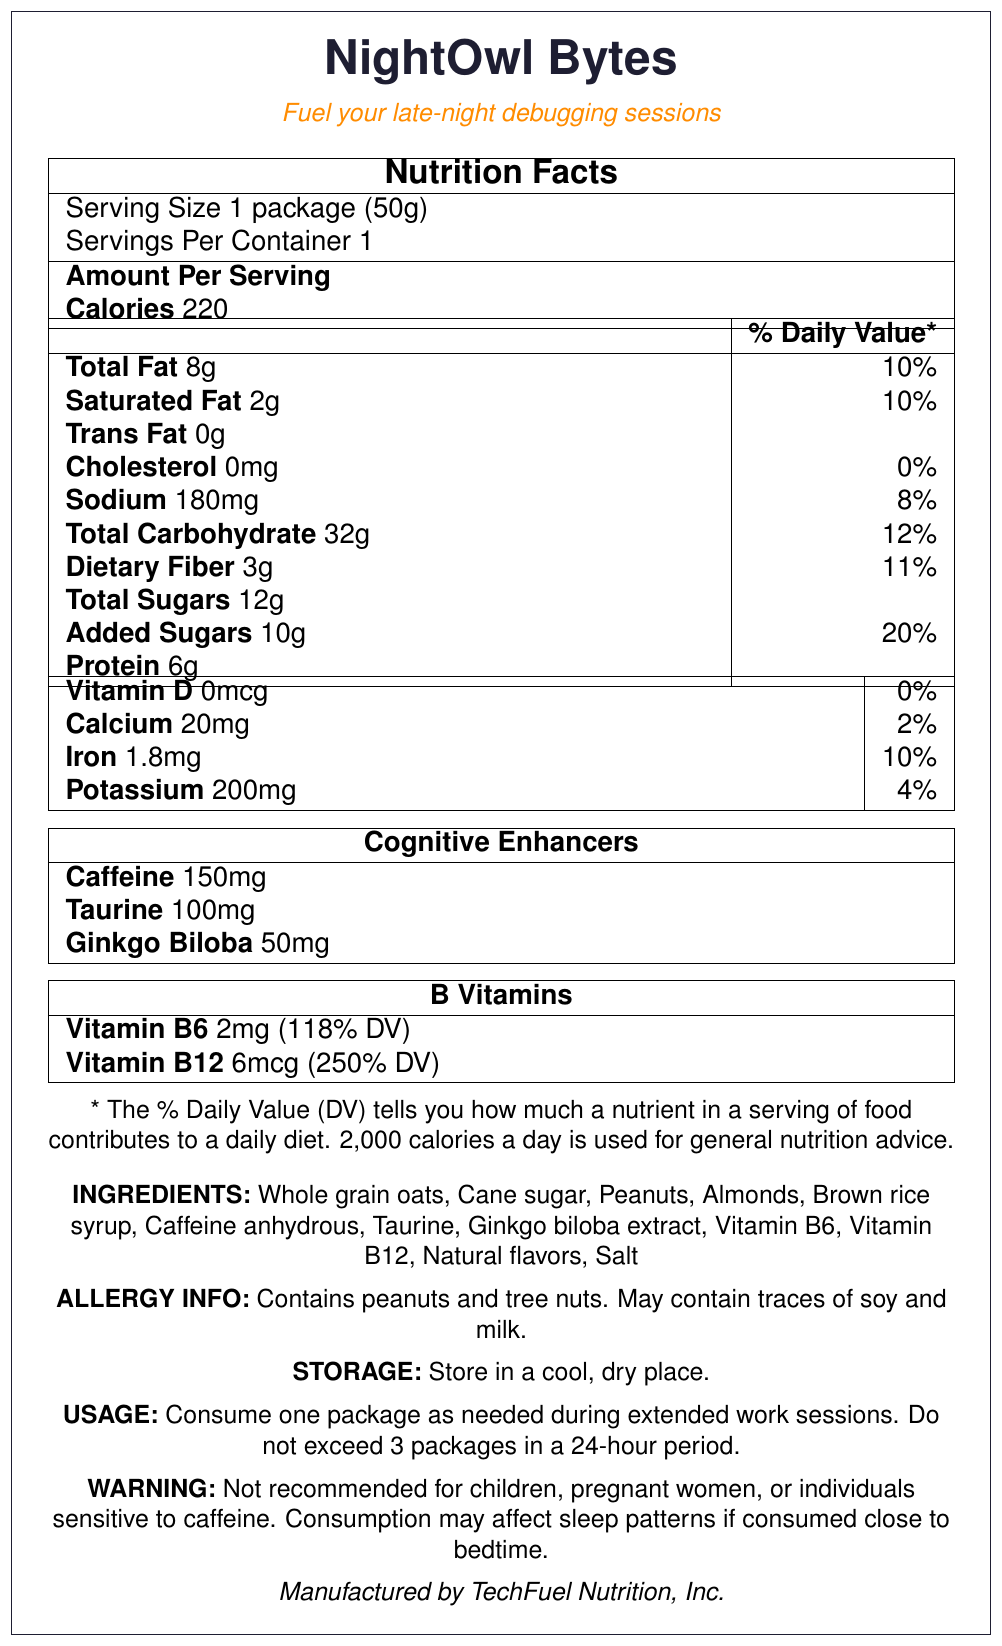what is the serving size for NightOwl Bytes? The serving size information is listed in the Nutrition Facts section.
Answer: 1 package (50g) how many calories are in one serving? The calorie content per serving is provided under the Nutrition Facts section.
Answer: 220 what is the amount of total fat per serving? Total fat amount is listed in the Nutrition Facts section under fat-related nutrients.
Answer: 8g how much protein is in each package of NightOwl Bytes? The protein content is listed in the Nutrition Facts section.
Answer: 6g what is the percentage of daily value for added sugars? The % daily value for added sugars is listed next to the amount in grams in the Nutrition Facts section.
Answer: 20% how much caffeine is included per serving? The caffeine content is listed under the Cognitive Enhancers section in the Nutrition Facts.
Answer: 150mg what is the primary function of NightOwl Bytes? This is mentioned in the product tagline below the product name.
Answer: Fuel your late-night debugging sessions. which of the following is NOT an ingredient in NightOwl Bytes? A. Whole grain oats B. Cane sugar C. Milk D. Peanuts The Ingredients list mentions Whole grain oats, Cane sugar, Peanuts, but Milk is only mentioned as potential traces in the allergy information.
Answer: C. Milk how much Vitamin B12 is in each serving and how does it compare to the % daily value? A. 2mg, 118% B. 6mcg, 100% C. 2mg, 100% D. 6mcg, 250% The Nutrition Facts section under B Vitamins lists 6mcg of Vitamin B12 and 250% of DV.
Answer: D. 6mcg, 250% is this product suitable for people with peanut allergies? The allergy information clearly states that the product contains peanuts and tree nuts.
Answer: No what is the recommended storage condition for NightOwl Bytes? Storage instructions are mentioned at the bottom of the document.
Answer: Store in a cool, dry place. summarize the main idea of the document. The document details the product name, tagline, nutrition facts, cognitive enhancers, ingredients, usage instructions, warning, and manufacturer information.
Answer: NightOwl Bytes are a snack designed for network engineers and distributed systems experts working late at night. The product provides balanced nutrition with cognitive enhancers like caffeine, taurine, and Ginkgo biloba, and includes comprehensive nutrition facts, ingredients, and usage instructions. how many servings are in each container? The serving information in the Nutrition Facts section states one serving per container.
Answer: 1 can I consume more than 3 packages of NightOwl Bytes in a day? The usage instructions specify not to exceed 3 packages in a 24-hour period.
Answer: No what is the source of dietary fiber in NightOwl Bytes? The document lists dietary fiber content but does not specify the source of the dietary fiber.
Answer: Cannot be determined who manufactures NightOwl Bytes? The manufacturer information is mentioned at the bottom of the document.
Answer: TechFuel Nutrition, Inc. 